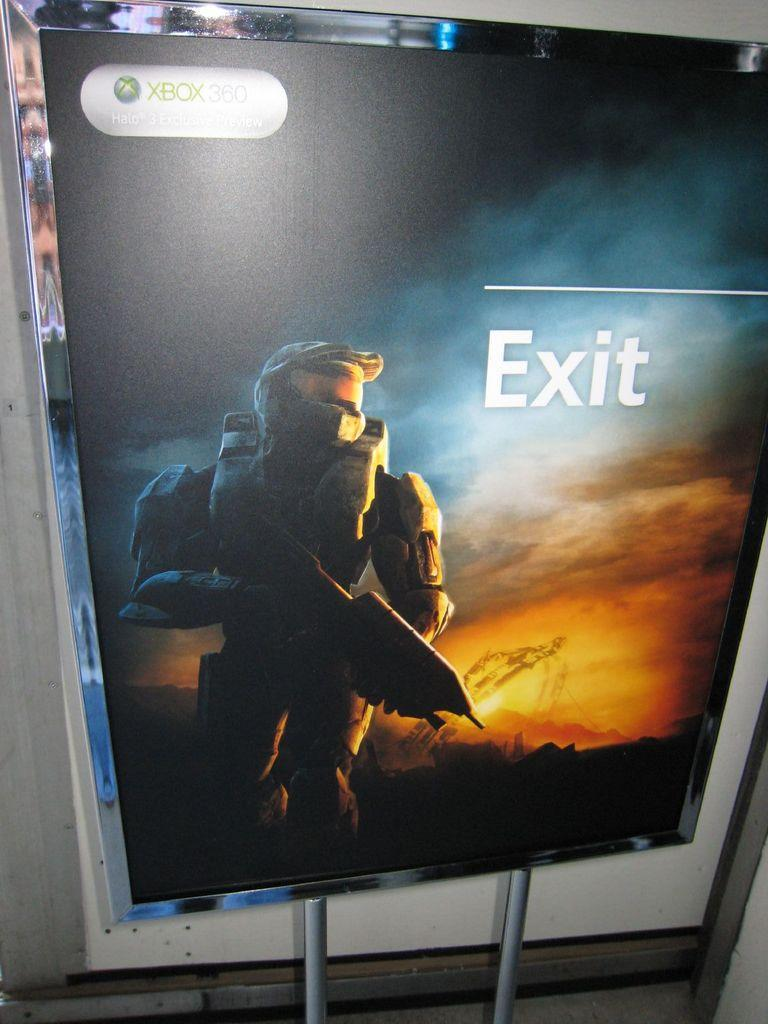Provide a one-sentence caption for the provided image. Exit the real world, and enter the world of Halo on Xbox 360. 